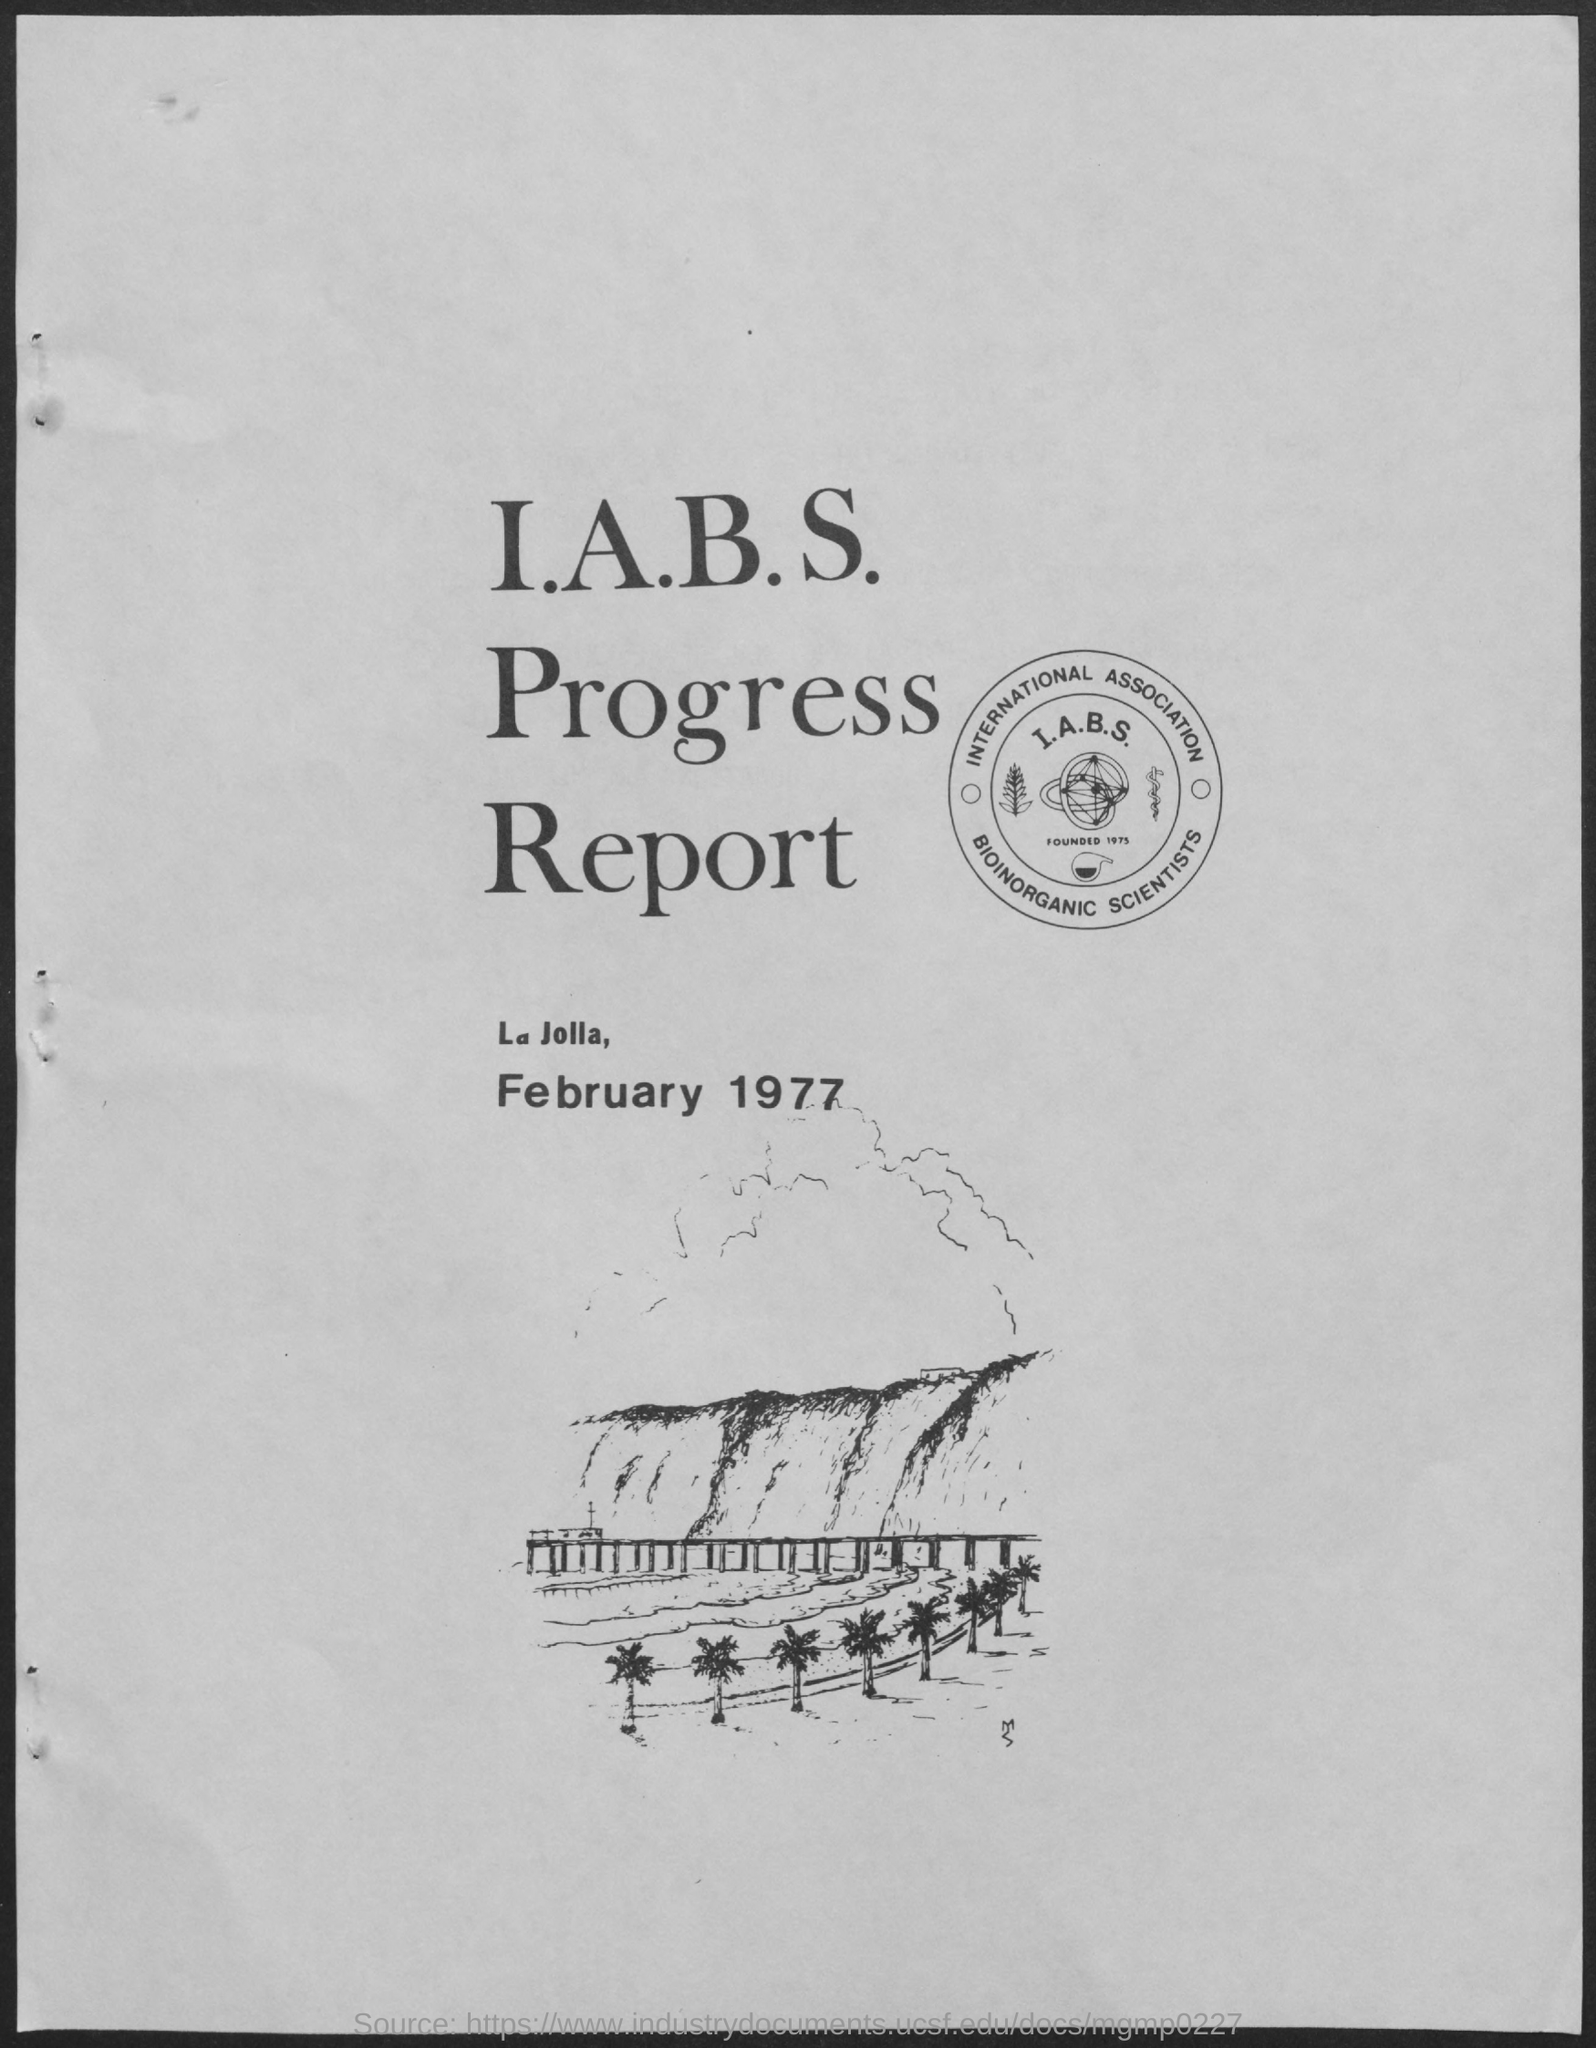What is the title of the document?
Provide a short and direct response. I.A.B.S Progress Report. What is the date mentioned in the document?
Ensure brevity in your answer.  February 1977. 